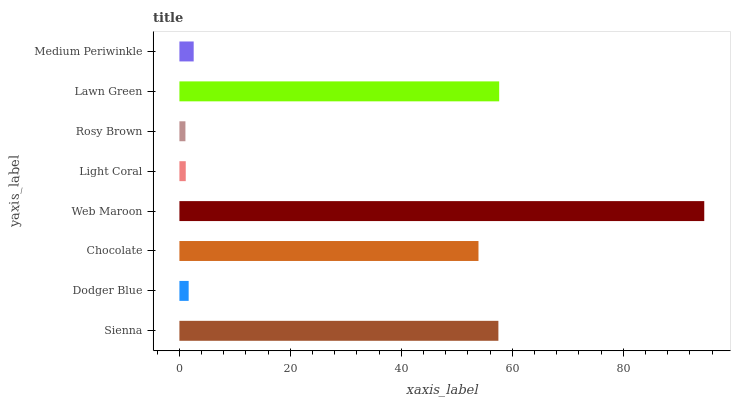Is Rosy Brown the minimum?
Answer yes or no. Yes. Is Web Maroon the maximum?
Answer yes or no. Yes. Is Dodger Blue the minimum?
Answer yes or no. No. Is Dodger Blue the maximum?
Answer yes or no. No. Is Sienna greater than Dodger Blue?
Answer yes or no. Yes. Is Dodger Blue less than Sienna?
Answer yes or no. Yes. Is Dodger Blue greater than Sienna?
Answer yes or no. No. Is Sienna less than Dodger Blue?
Answer yes or no. No. Is Chocolate the high median?
Answer yes or no. Yes. Is Medium Periwinkle the low median?
Answer yes or no. Yes. Is Rosy Brown the high median?
Answer yes or no. No. Is Light Coral the low median?
Answer yes or no. No. 